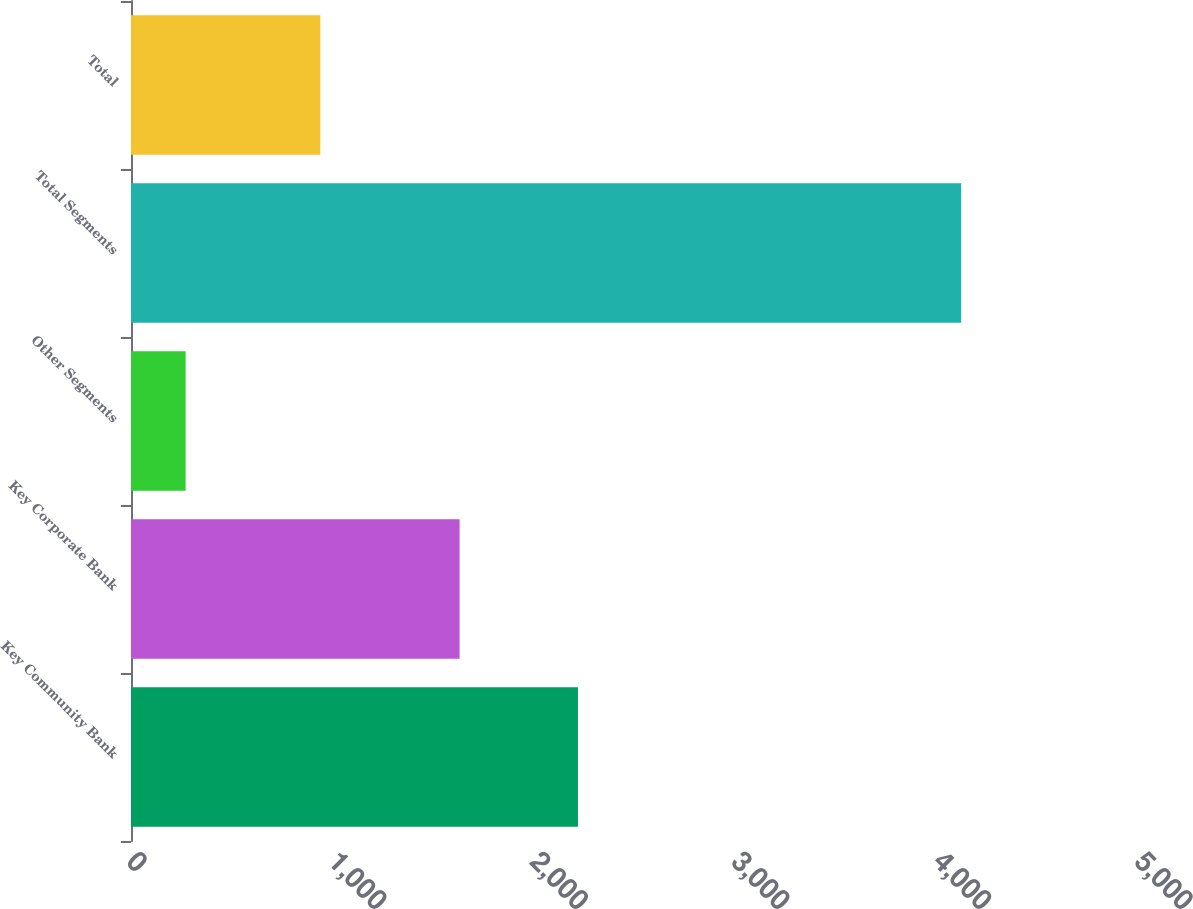<chart> <loc_0><loc_0><loc_500><loc_500><bar_chart><fcel>Key Community Bank<fcel>Key Corporate Bank<fcel>Other Segments<fcel>Total Segments<fcel>Total<nl><fcel>2217<fcel>1630<fcel>271<fcel>4118<fcel>939<nl></chart> 